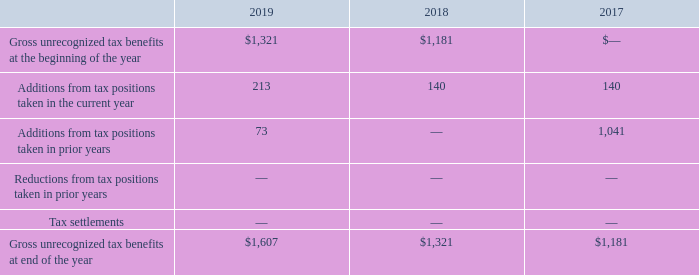Uncertain Tax Positions
In accordance with authoritative guidance, the impact of an uncertain income tax position on the income tax return must be recognized at the largest amount that is more-likely-than-not to be sustained upon audit by the relevant taxing authority. An uncertain income tax position will not be recognized if it has less than a 50% likelihood of being sustained.
The following table reconciles the beginning and ending amount of unrecognized tax benefits for the fiscal years ended September 30, 2019, 2018,and 2017 (amounts shown in thousands):
Of the total unrecognized tax benefits at September 30, 2019, $1.6 million will impact the Company’s effective tax rate. The Company does not anticipate that there will be a substantial change in unrecognized tax benefits within the next twelve months.
The Company's practice is to recognize interest and/or penalties related to income tax matters in income tax expense. As of September 30, 2019, no accrued interest or penalties related to uncertain tax positions are recorded in the consolidated financial statements.
The Company is subject to income taxation in the U.S. at the federal and state levels. All tax years are subject to examination by U.S., California, and other state tax authorities due to the carryforward of unutilized net operating losses and tax credits. The Company is also subject to foreign income taxes in the countries in which it operates. The Company’s U.S. federal tax return for the year ended September 30, 2017 is currently under examination. To our knowledge, the Company is not currently under examination by any other taxing authorities.
What is the condition when an uncertain income tax position will not be recognized? If it has less than a 50% likelihood of being sustained. How much of total unrecognized tax benefits will impact the Company’s effective tax rate on September 30, 2019? $1.6 million. What is the gross unrecognized tax benefit at the end of the year 2018?
Answer scale should be: thousand. $1,321. What is the average gross unrecognized tax benefit at the end of the year from 2017 to 2019?
Answer scale should be: thousand. (1,607+1,321+1,181)/3 
Answer: 1369.67. What is the proportion of addition from tax positions taken in the current year and prior years over gross unrecognized tax benefit at the end of the year 2019? (213+73)/1,607 
Answer: 0.18. What is the percentage change in gross unrecognized tax benefits at the beginning of the year from 2018 to 2019?
Answer scale should be: percent. (1,321-1,181)/1,181 
Answer: 11.85. 